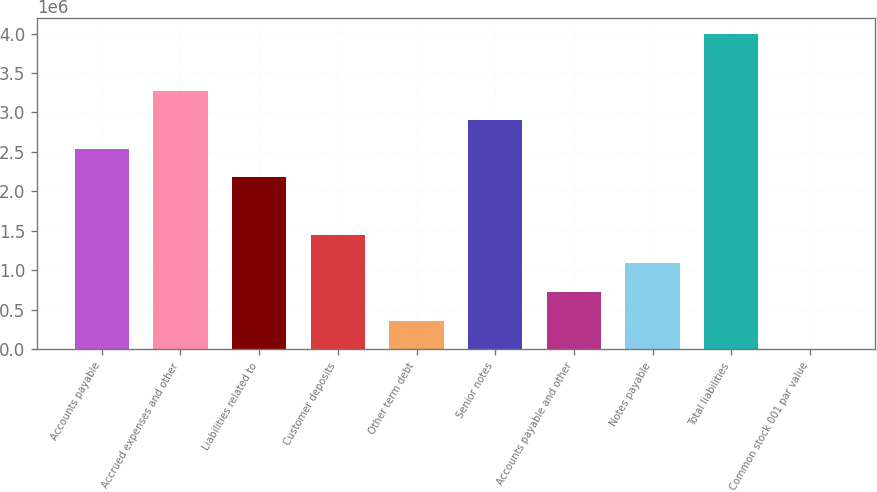Convert chart. <chart><loc_0><loc_0><loc_500><loc_500><bar_chart><fcel>Accounts payable<fcel>Accrued expenses and other<fcel>Liabilities related to<fcel>Customer deposits<fcel>Other term debt<fcel>Senior notes<fcel>Accounts payable and other<fcel>Notes payable<fcel>Total liabilities<fcel>Common stock 001 par value<nl><fcel>2.54168e+06<fcel>3.26782e+06<fcel>2.17861e+06<fcel>1.45248e+06<fcel>363274<fcel>2.90475e+06<fcel>726342<fcel>1.08941e+06<fcel>3.99396e+06<fcel>206<nl></chart> 